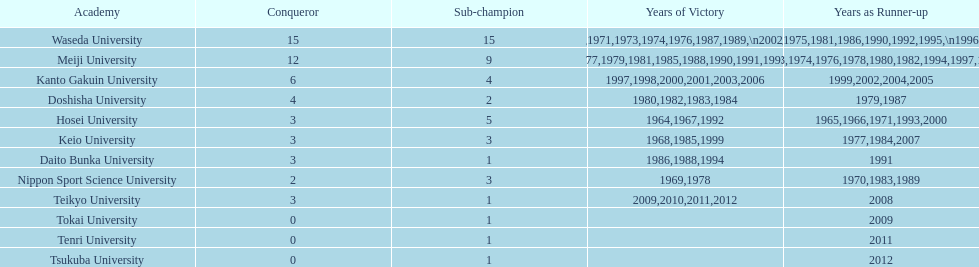Help me parse the entirety of this table. {'header': ['Academy', 'Conqueror', 'Sub-champion', 'Years of Victory', 'Years as Runner-up'], 'rows': [['Waseda University', '15', '15', '1965,1966,1968,1970,1971,1973,1974,1976,1987,1989,\\n2002,2004,2005,2007,2008', '1964,1967,1969,1972,1975,1981,1986,1990,1992,1995,\\n1996,2001,2003,2006,2010'], ['Meiji University', '12', '9', '1972,1975,1977,1979,1981,1985,1988,1990,1991,1993,\\n1995,1996', '1973,1974,1976,1978,1980,1982,1994,1997,1998'], ['Kanto Gakuin University', '6', '4', '1997,1998,2000,2001,2003,2006', '1999,2002,2004,2005'], ['Doshisha University', '4', '2', '1980,1982,1983,1984', '1979,1987'], ['Hosei University', '3', '5', '1964,1967,1992', '1965,1966,1971,1993,2000'], ['Keio University', '3', '3', '1968,1985,1999', '1977,1984,2007'], ['Daito Bunka University', '3', '1', '1986,1988,1994', '1991'], ['Nippon Sport Science University', '2', '3', '1969,1978', '1970,1983,1989'], ['Teikyo University', '3', '1', '2009,2010,2011,2012', '2008'], ['Tokai University', '0', '1', '', '2009'], ['Tenri University', '0', '1', '', '2011'], ['Tsukuba University', '0', '1', '', '2012']]} How many championships does nippon sport science university have 2. 